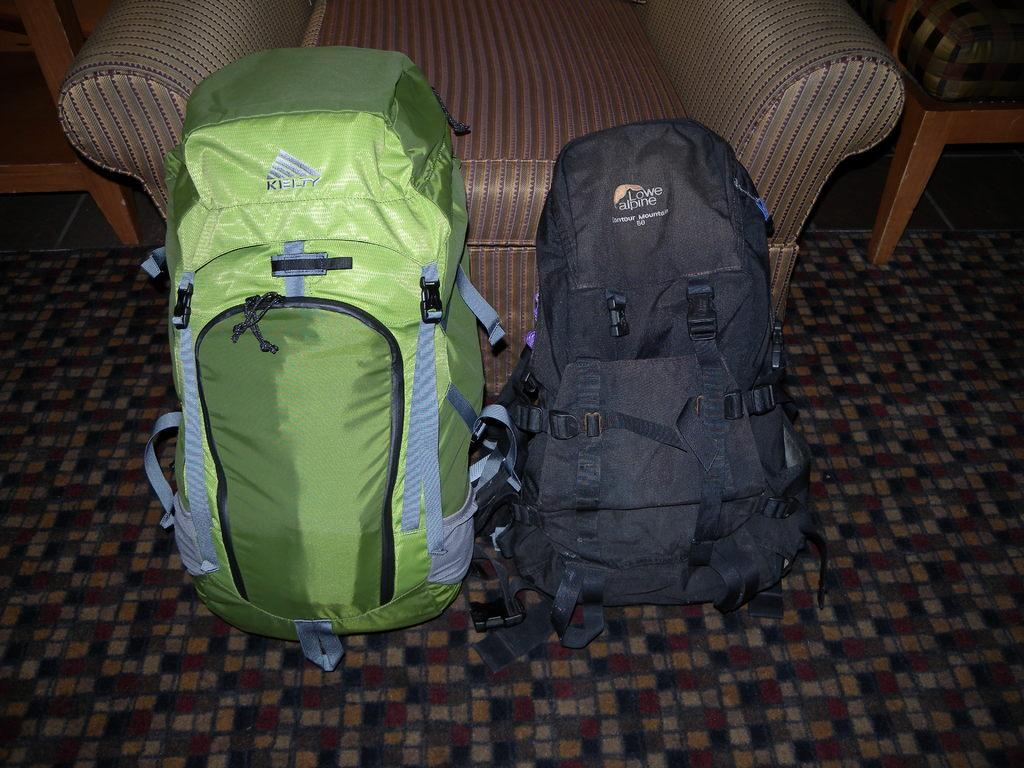What objects are on the floor in the image? There are two backpacks on the floor. What type of furniture is in the image? There is a sofa and two chairs beside the sofa. What is covering the floor in the image? There is a carpet on the floor. What holiday is being celebrated in the image? There is no indication of a holiday being celebrated in the image. How many times do the backpacks jump in the image? Backpacks cannot jump, as they are inanimate objects. 